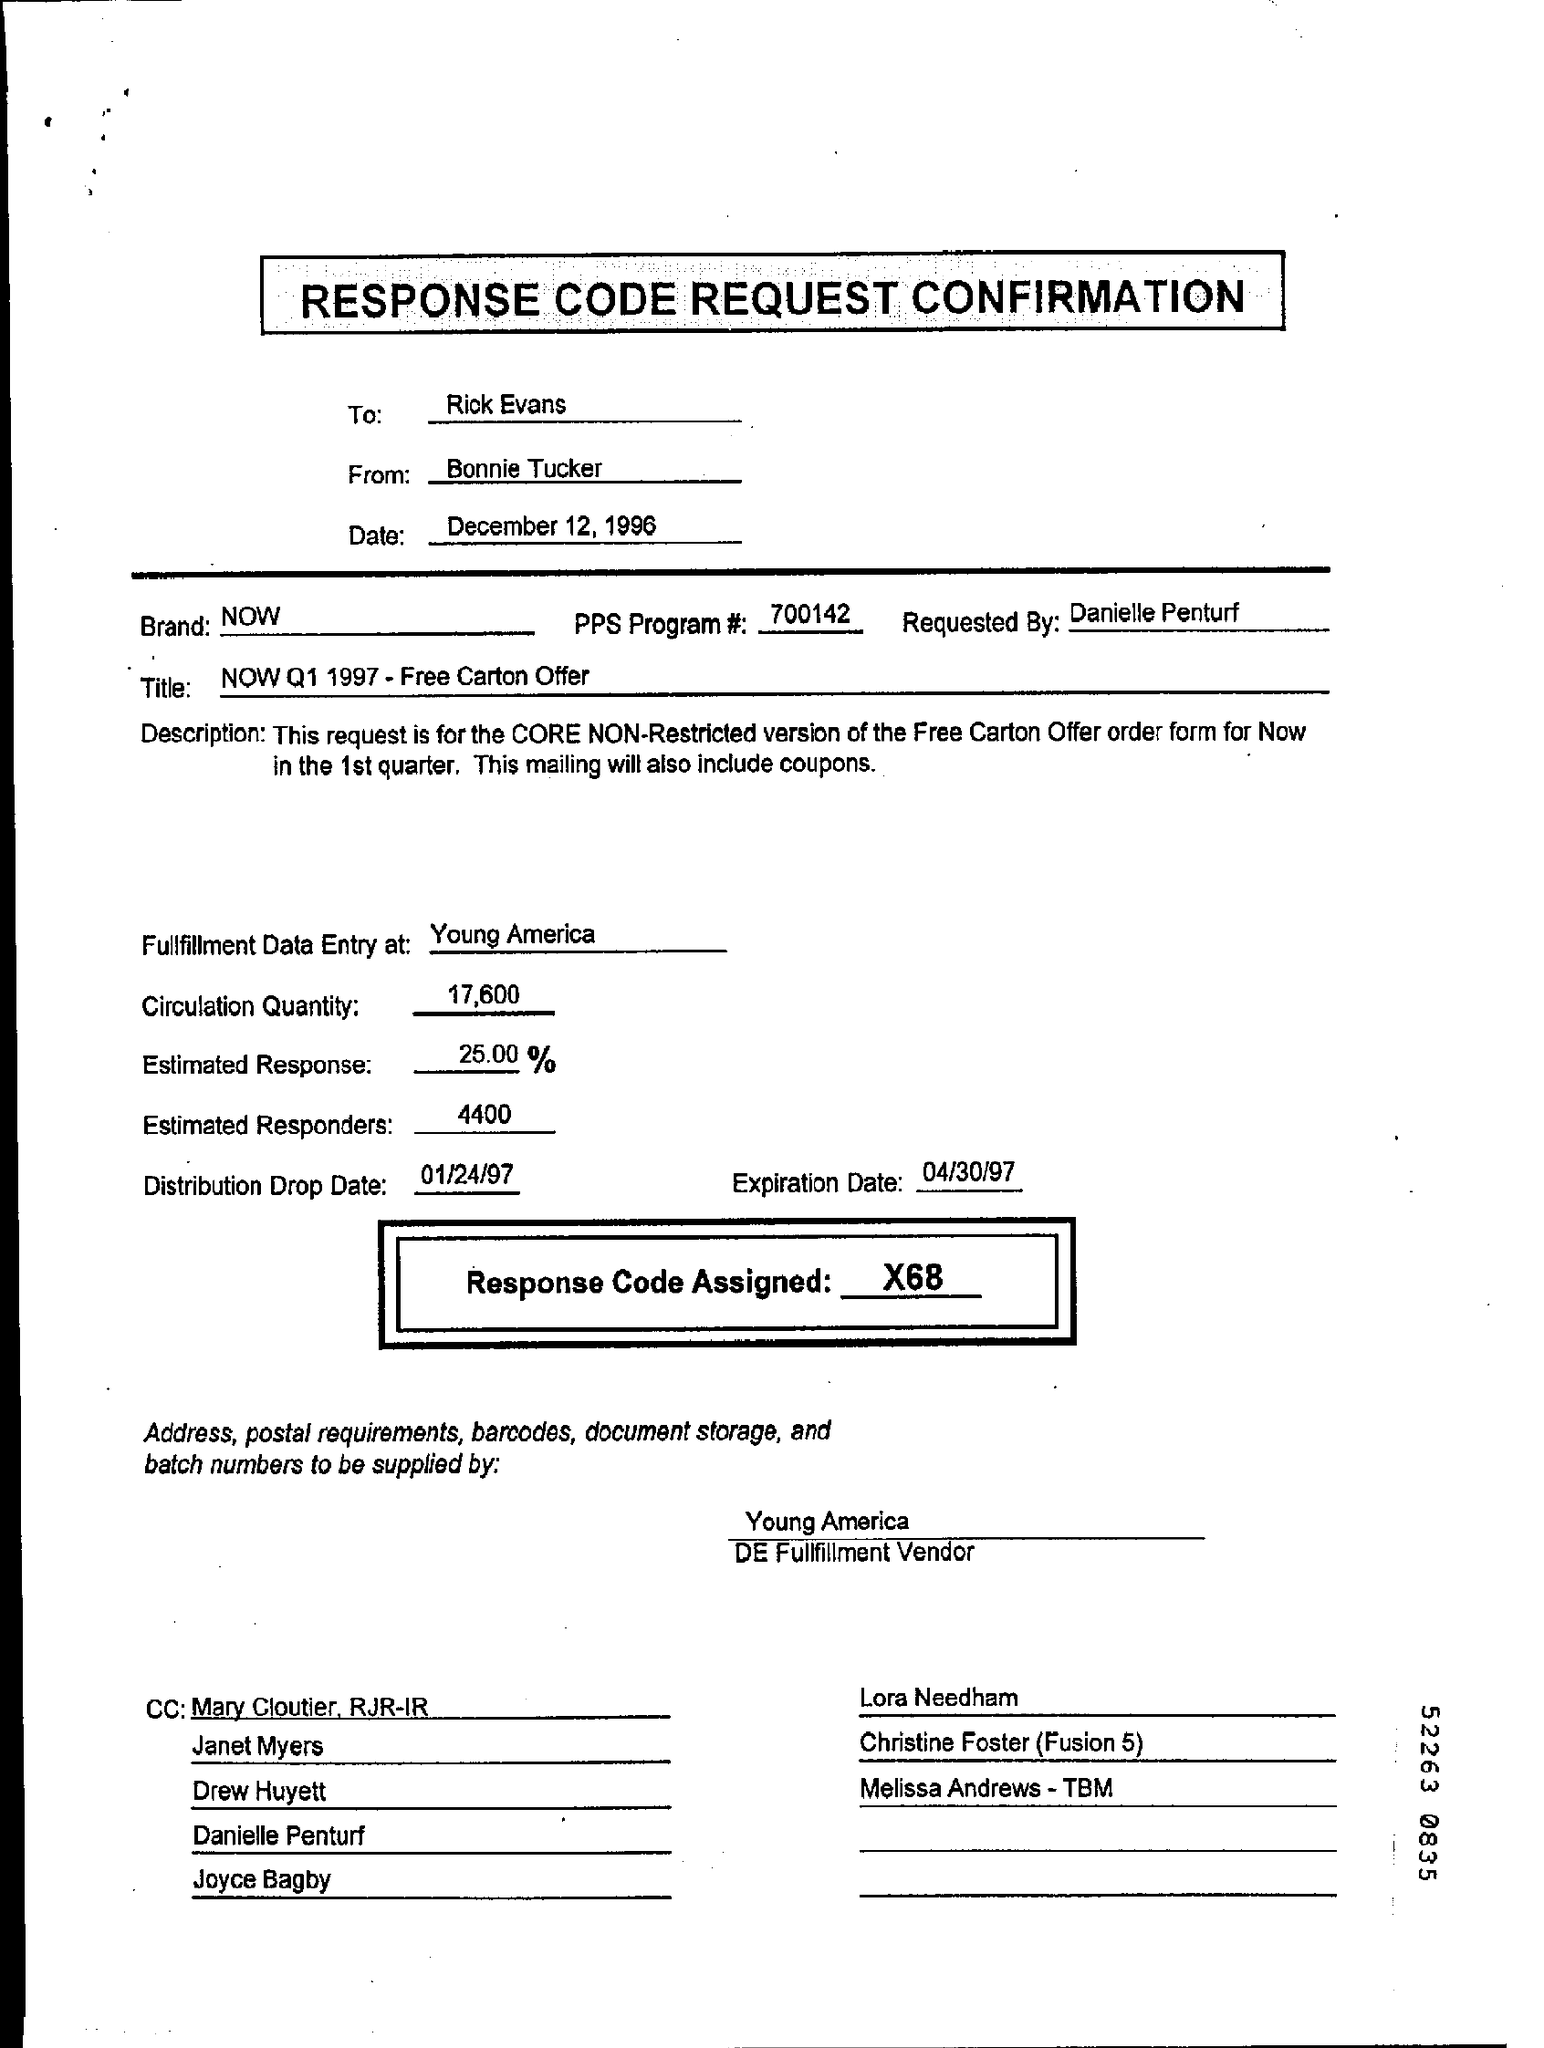To whom this letter is sent ?
Make the answer very short. Rick Evans. What is the response code assigned ?
Provide a succinct answer. X68. What is the expiration date ?
Offer a very short reply. 04/30/97. What is the distribution drop date ?
Your answer should be compact. 01/24/97. How much is the estimated responders ?
Your response must be concise. 4400. Where is the fulfilment data entry at ?
Give a very brief answer. Young America. 